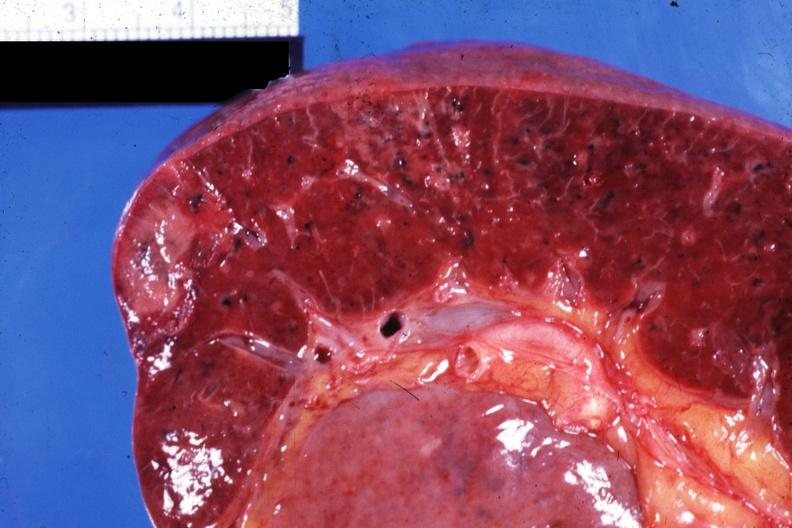what is present?
Answer the question using a single word or phrase. Hematologic 